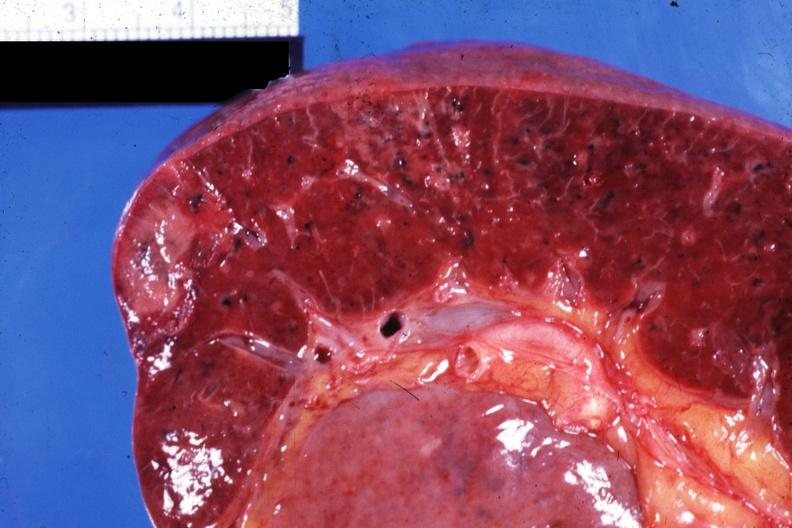what is present?
Answer the question using a single word or phrase. Hematologic 